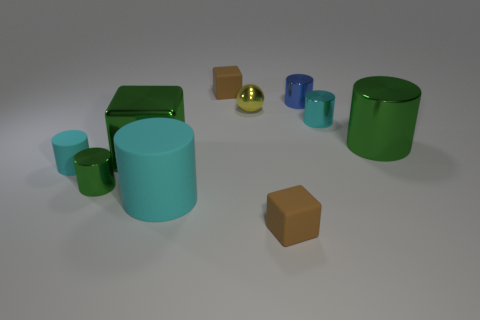There is a large cylinder that is the same color as the shiny block; what material is it?
Offer a terse response. Metal. What number of cylinders are either cyan metal things or tiny green objects?
Make the answer very short. 2. Is the green block made of the same material as the tiny green thing?
Your answer should be compact. Yes. What number of other things are the same color as the big matte cylinder?
Your answer should be compact. 2. What is the shape of the small brown rubber thing that is behind the tiny green metal cylinder?
Make the answer very short. Cube. How many things are small brown blocks or big cyan objects?
Provide a short and direct response. 3. Does the blue cylinder have the same size as the brown object that is to the left of the small yellow metal ball?
Provide a short and direct response. Yes. What number of other objects are there of the same material as the small green object?
Your response must be concise. 5. What number of objects are either cyan things behind the big shiny cube or matte cylinders that are behind the big cyan matte cylinder?
Your answer should be compact. 2. What material is the tiny blue object that is the same shape as the tiny cyan metallic thing?
Offer a terse response. Metal. 